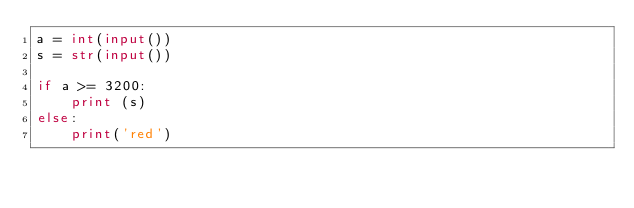Convert code to text. <code><loc_0><loc_0><loc_500><loc_500><_Python_>a = int(input())
s = str(input())

if a >= 3200:
    print (s)
else:
    print('red')</code> 